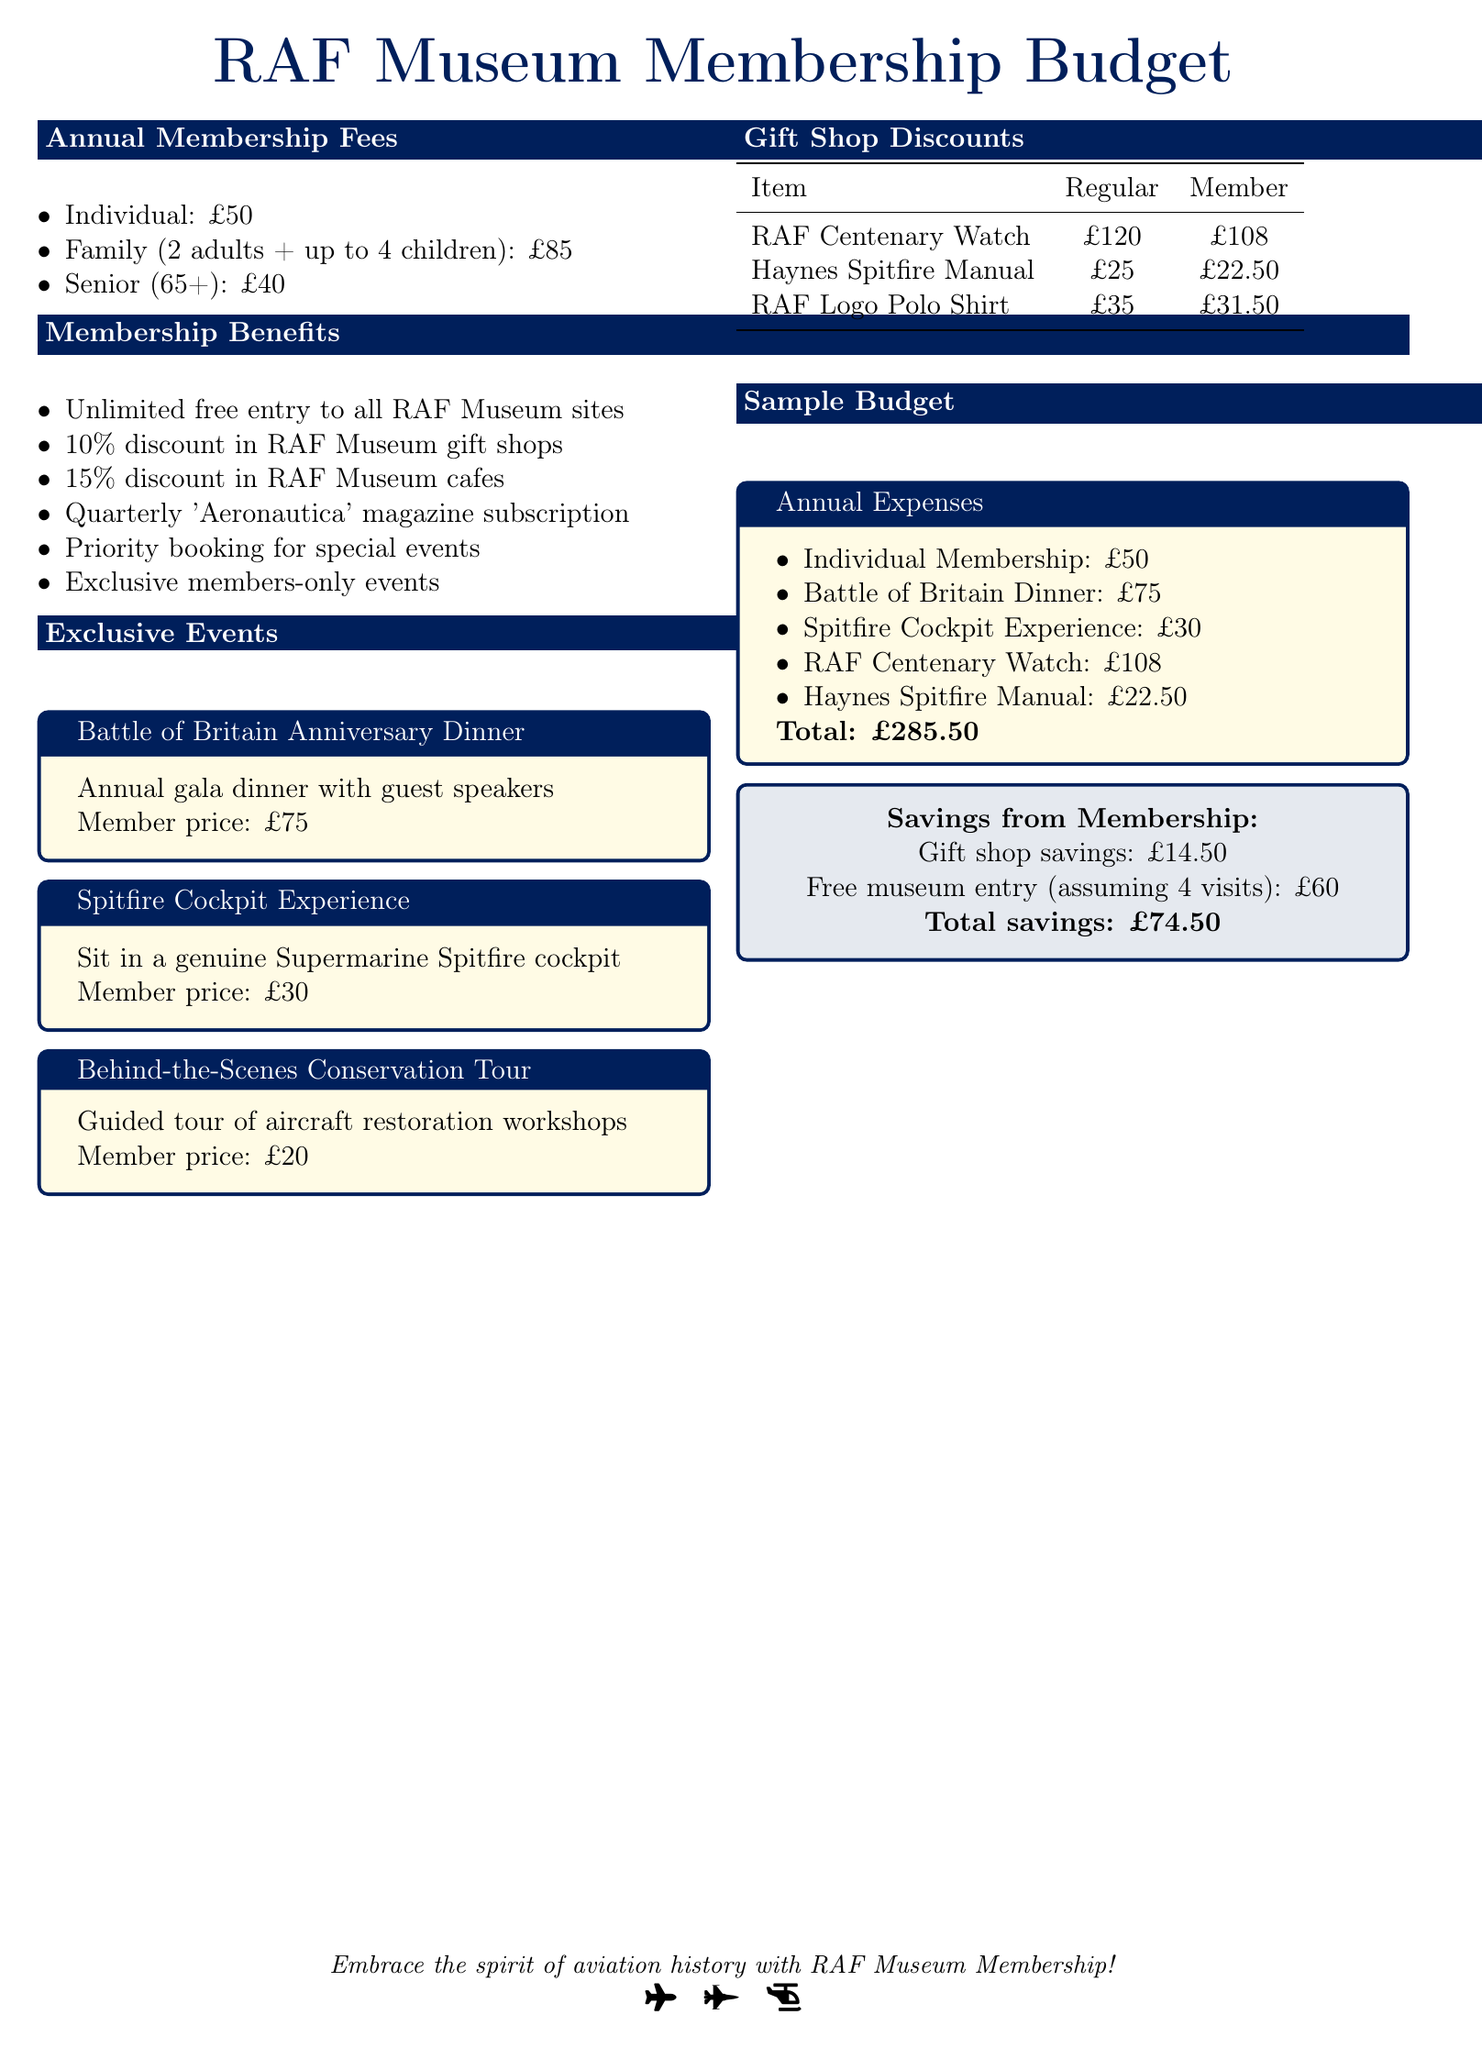What is the individual membership fee? The individual membership fee is stated in the document as £50.
Answer: £50 What discount do members receive in the gift shop? The document specifies a 10% discount for members in RAF Museum gift shops.
Answer: 10% How much is the senior membership fee? The document provides the senior membership fee as £40.
Answer: £40 What is the member price for the Spitfire Cockpit Experience? The Spitfire Cockpit Experience member price is listed as £30 in the document.
Answer: £30 What is the total savings from the membership listed in the document? The document states the total savings from membership as £74.50, calculated from different savings.
Answer: £74.50 How many children are included in the family membership? The family membership includes up to 4 children as mentioned in the document.
Answer: 4 children What is the member price for the Battle of Britain Anniversary Dinner? This price is detailed in the document as £75 for members attending the dinner.
Answer: £75 What does the quarterly subscription include? The document indicates that the quarterly subscription includes the 'Aeronautica' magazine.
Answer: 'Aeronautica' magazine What is the regular price of the RAF Centenary Watch? The regular price of the RAF Centenary Watch is £120, as per the table in the document.
Answer: £120 